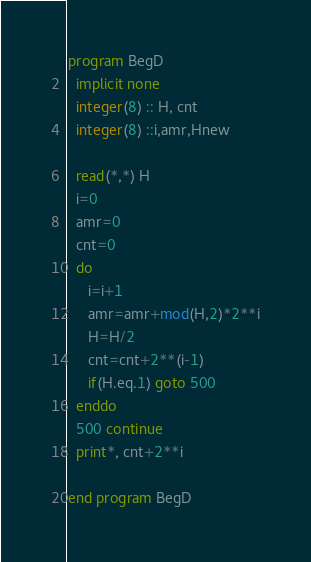<code> <loc_0><loc_0><loc_500><loc_500><_FORTRAN_>program BegD
  implicit none
  integer(8) :: H, cnt
  integer(8) ::i,amr,Hnew

  read(*,*) H
  i=0
  amr=0
  cnt=0
  do
     i=i+1
     amr=amr+mod(H,2)*2**i
     H=H/2
     cnt=cnt+2**(i-1)
     if(H.eq.1) goto 500
  enddo
  500 continue
  print*, cnt+2**i

end program BegD
</code> 